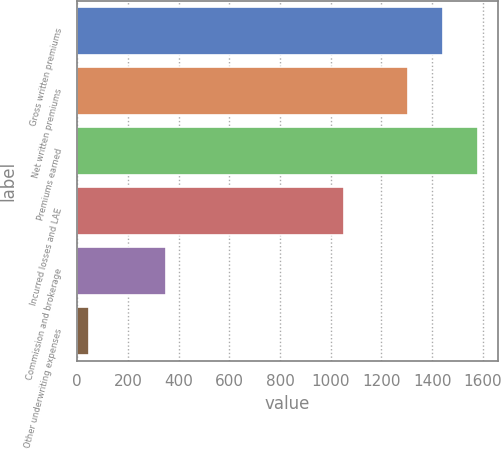Convert chart. <chart><loc_0><loc_0><loc_500><loc_500><bar_chart><fcel>Gross written premiums<fcel>Net written premiums<fcel>Premiums earned<fcel>Incurred losses and LAE<fcel>Commission and brokerage<fcel>Other underwriting expenses<nl><fcel>1443.66<fcel>1306.5<fcel>1580.82<fcel>1050.4<fcel>350.6<fcel>44.8<nl></chart> 